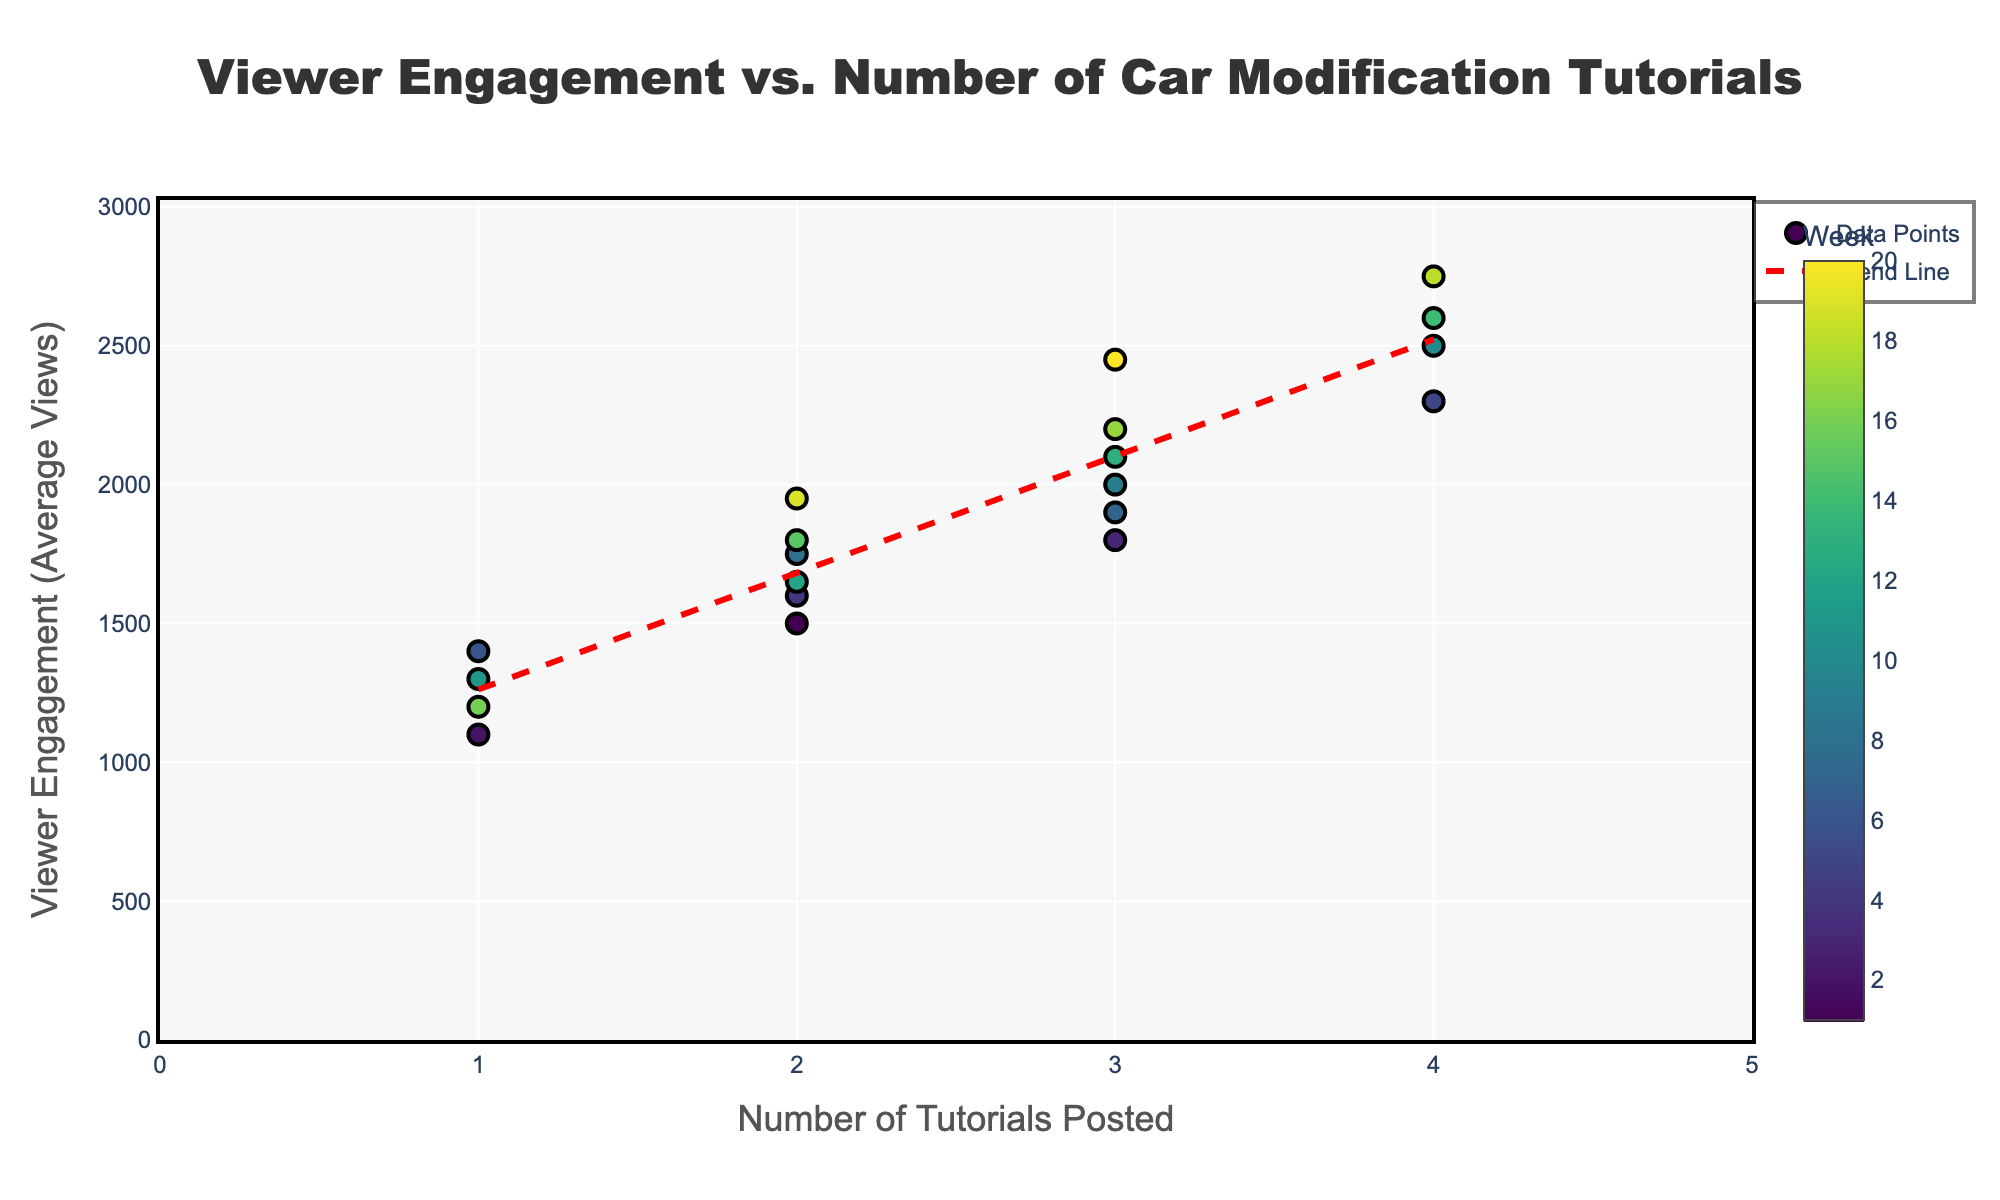How many car modification tutorials were posted in week 10? Look at the scatter plot and locate the value on the x-axis (Number of Tutorials Posted) corresponding to the color associated with week 10 on the color scale.
Answer: 4 What's the title of the scatter plot? The title is positioned at the top center of the plot and is usually in a larger font size.
Answer: Viewer Engagement vs. Number of Car Modification Tutorials How does viewer engagement change with the number of tutorials posted? Observe the trend line that indicates the general direction of data points; it shows how viewer engagement (y-axis) varies as the number of tutorials posted (x-axis) increases.
Answer: Increases What is the average viewer engagement when 3 tutorials are posted? Locate the data points on the plot corresponding to 3 tutorials posted and find the average of their y-values.
Answer: 2100 Which week corresponds to the maximum viewer engagement, and how many tutorials were posted that week? Identify the peak y-value on the plot; then look at the color scale to determine the associated week, and find the corresponding x-value to identify the number of tutorials posted.
Answer: Week 18, 4 tutorials Is there any week where the viewer engagement is below 1200 views? Check the y-axis for values below 1200 and see if any data points fall under that threshold.
Answer: No What is the range of viewer engagement for weeks where 2 tutorials were posted? Find all data points where the x-value is 2 and determine the minimum and maximum y-values for these points.
Answer: 1500 to 1950 Does the trend line accurately represent the data points? Compare the red dashed trend line to the distribution of all data points to see if it reasonably follows the overall pattern.
Answer: Yes Which color represents week 1, and what are its viewer engagement levels? Refer to the color scale to find the color for week 1 and then locate its data points on the plot to find their y-values.
Answer: A shade at the end of the Viridis color scale, 1500 How many data points are plotted in total? Count all the individual markers (data points) on the scatter plot.
Answer: 20 